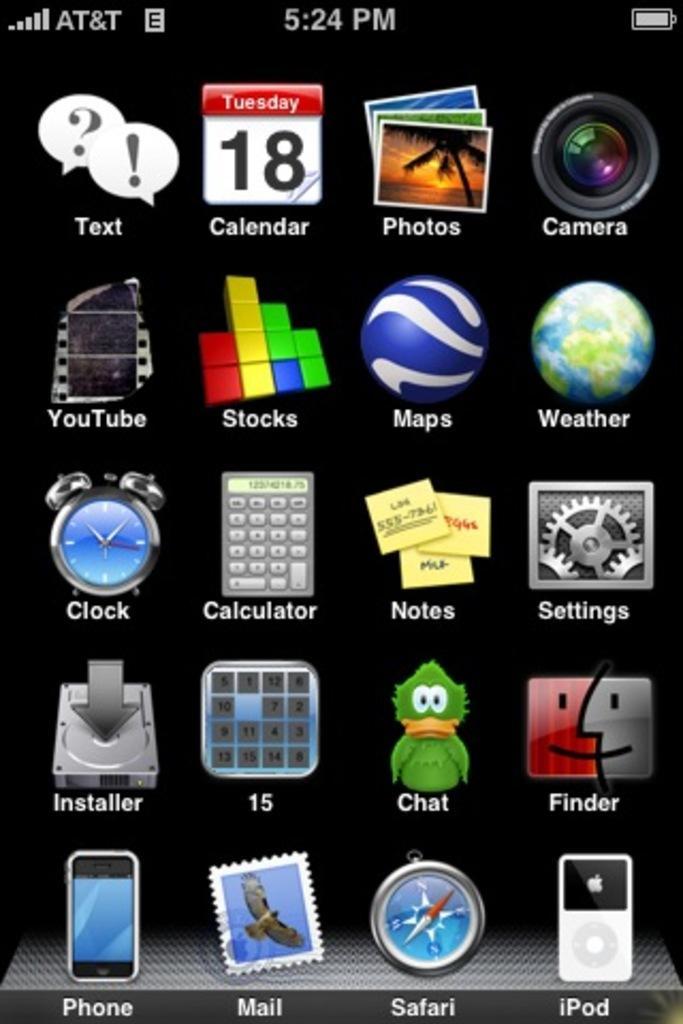In one or two sentences, can you explain what this image depicts? This picture shows a screenshot. we see apps in the screenshot. 